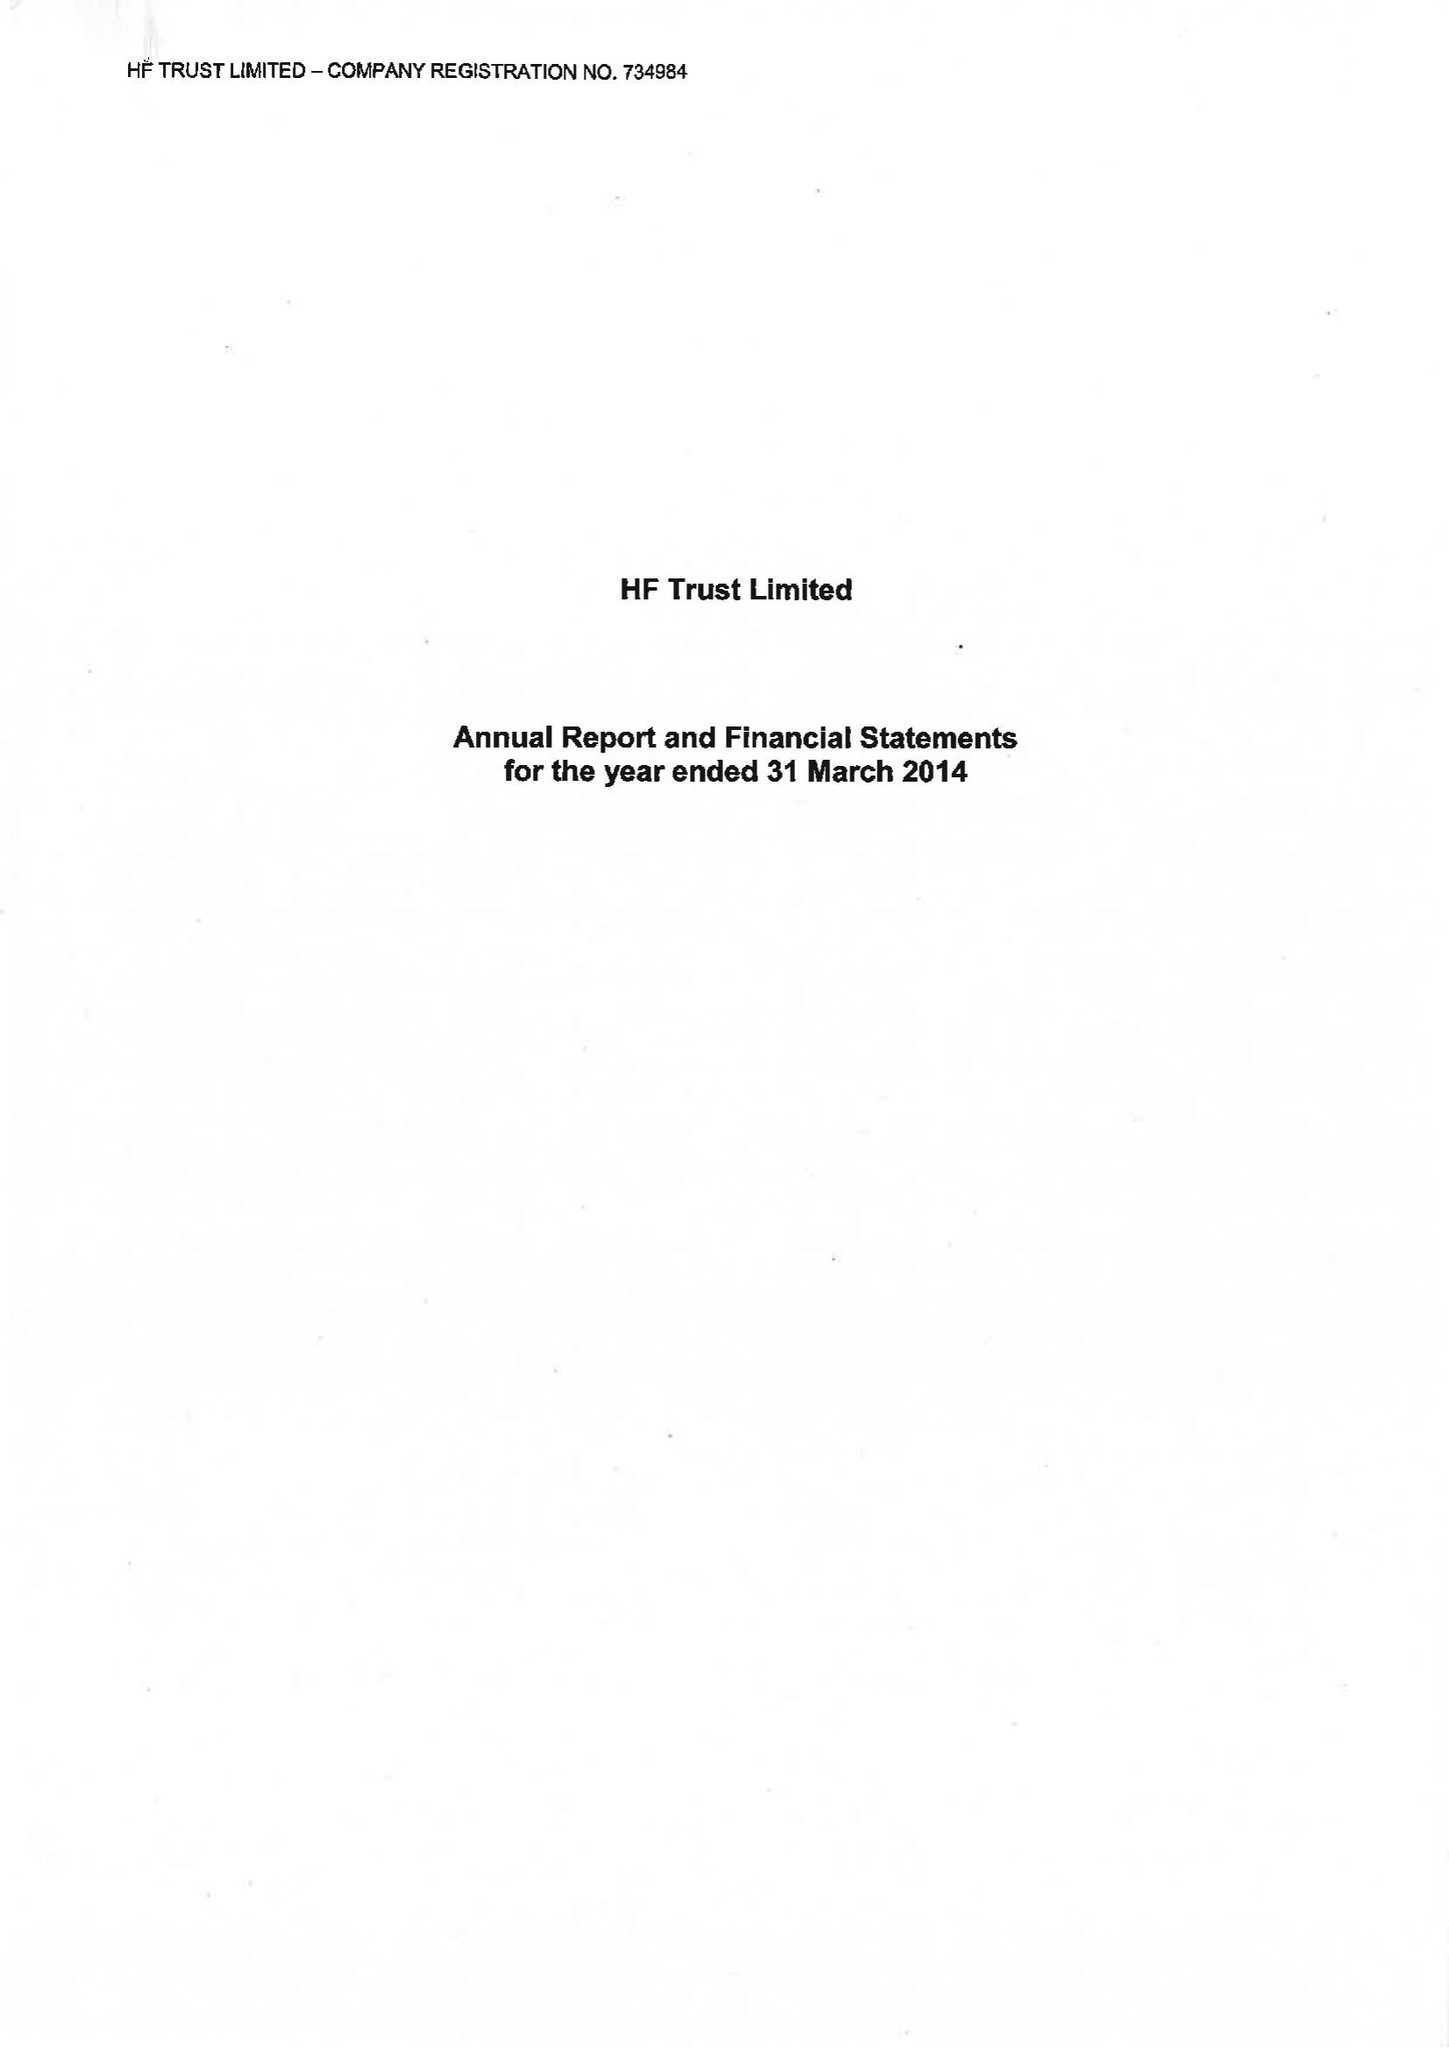What is the value for the address__postcode?
Answer the question using a single word or phrase. BS16 7FL 